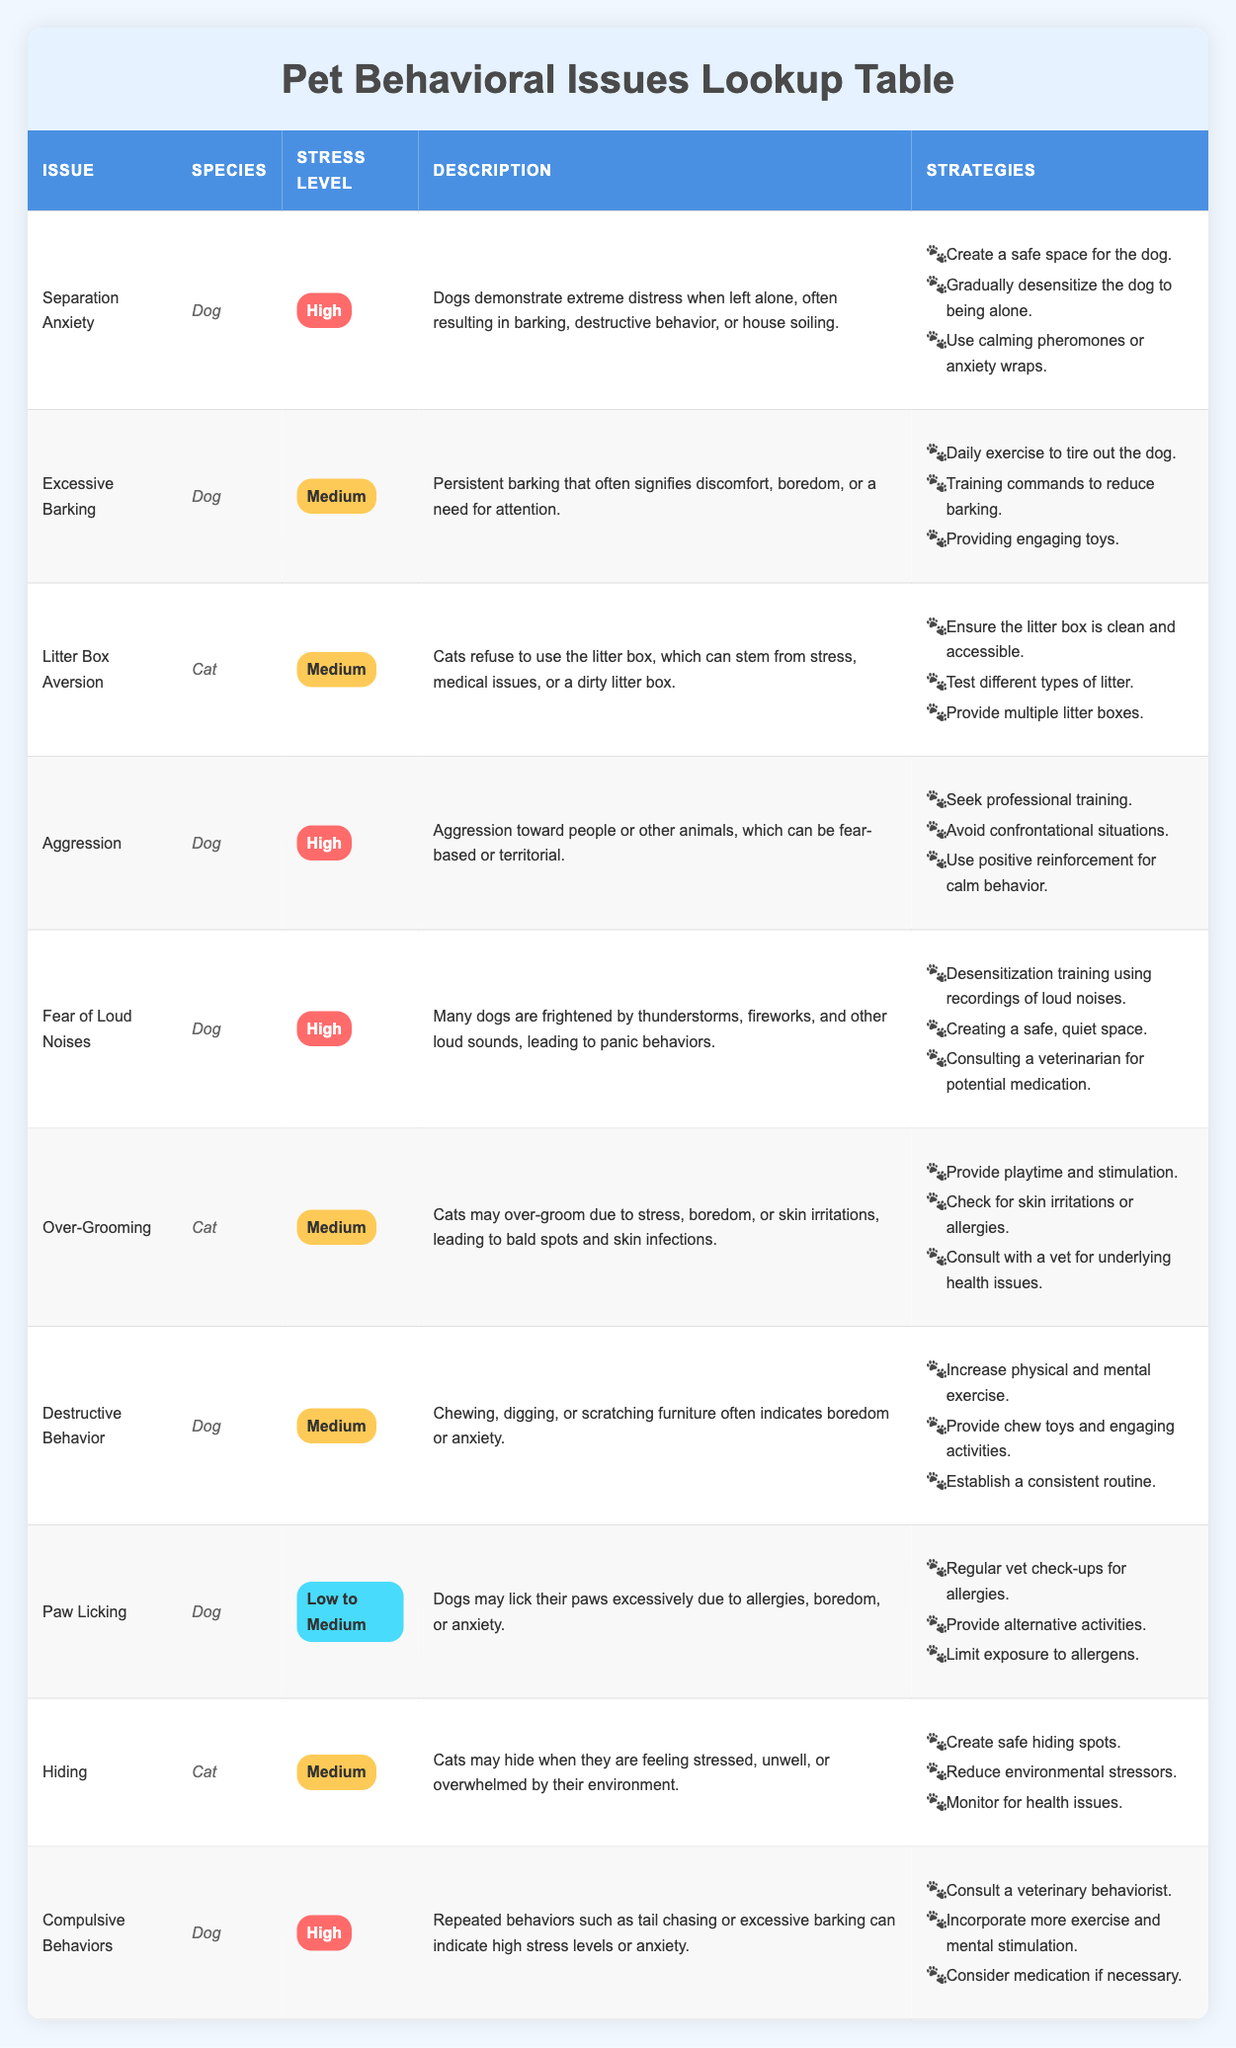What is the stress level associated with Separation Anxiety in dogs? The stress level for Separation Anxiety in dogs is listed in the table as "High."
Answer: High Which species shows a behavioral issue of Over-Grooming? The species associated with Over-Grooming, according to the table, is "Cat."
Answer: Cat How many behavioral issues are categorized as having a high stress level? There are four issues indicated in the table as having a high stress level: Separation Anxiety, Aggression, Fear of Loud Noises, and Compulsive Behaviors.
Answer: 4 Is Litter Box Aversion considered a high stress level behavioral issue? No, Litter Box Aversion has a stress level listed as "Medium," not "High."
Answer: No What strategies can be applied to manage Aggression in dogs? The strategies listed for managing Aggression in dogs are: Seek professional training, Avoid confrontational situations, and Use positive reinforcement for calm behavior.
Answer: Seek professional training, avoid confrontational situations, use positive reinforcement Which behavioral issue in cats is characterized by hiding? The issue that involves hiding in cats is referred to as "Hiding," as stated in the table.
Answer: Hiding What is the average stress level across all behavioral issues listed for dogs? The stress levels for the listed behavioral issues in dogs are High (4), Medium (3), and Low to Medium (1). This results in a total of 8 values, where "High" equals 3, "Medium" equals 3, and "Low to Medium" is 0.5. The average can be calculated as (3*3 + 3*2 + 0.5) / 8 = 2.5 / 8 = 0.3125, and if we consider a qualitative average, it tends toward "Medium."
Answer: Medium What are the common strategies to reduce Excessive Barking in dogs? The strategies provided for addressing Excessive Barking are: Daily exercise to tire out the dog, Training commands to reduce barking, and Providing engaging toys.
Answer: Daily exercise, training commands, providing engaging toys How does Fear of Loud Noises impact dogs according to the table? Fear of Loud Noises is indicated in the table to cause panic behaviors in dogs during thunderstorms, fireworks, and other loud sounds, illustrating a high level of distress.
Answer: High stress and panic behaviors 